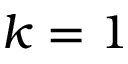<formula> <loc_0><loc_0><loc_500><loc_500>k = 1</formula> 